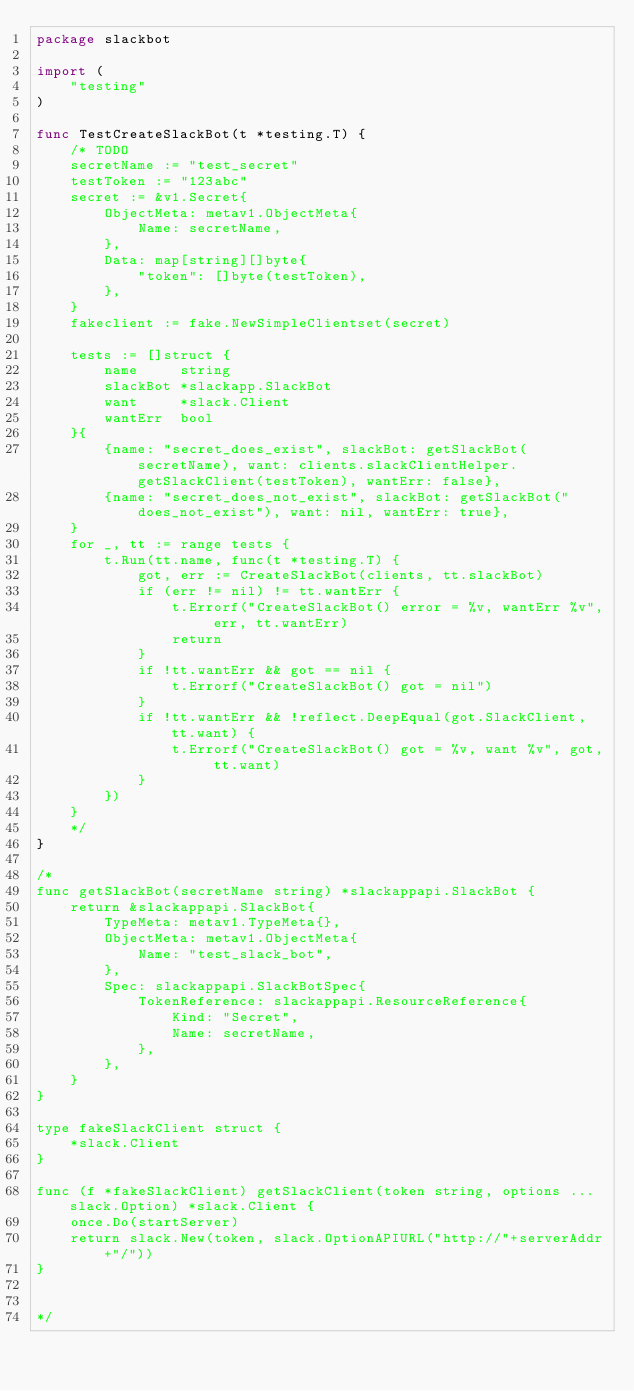Convert code to text. <code><loc_0><loc_0><loc_500><loc_500><_Go_>package slackbot

import (
	"testing"
)

func TestCreateSlackBot(t *testing.T) {
	/* TODO
	secretName := "test_secret"
	testToken := "123abc"
	secret := &v1.Secret{
		ObjectMeta: metav1.ObjectMeta{
			Name: secretName,
		},
		Data: map[string][]byte{
			"token": []byte(testToken),
		},
	}
	fakeclient := fake.NewSimpleClientset(secret)

	tests := []struct {
		name     string
		slackBot *slackapp.SlackBot
		want     *slack.Client
		wantErr  bool
	}{
		{name: "secret_does_exist", slackBot: getSlackBot(secretName), want: clients.slackClientHelper.getSlackClient(testToken), wantErr: false},
		{name: "secret_does_not_exist", slackBot: getSlackBot("does_not_exist"), want: nil, wantErr: true},
	}
	for _, tt := range tests {
		t.Run(tt.name, func(t *testing.T) {
			got, err := CreateSlackBot(clients, tt.slackBot)
			if (err != nil) != tt.wantErr {
				t.Errorf("CreateSlackBot() error = %v, wantErr %v", err, tt.wantErr)
				return
			}
			if !tt.wantErr && got == nil {
				t.Errorf("CreateSlackBot() got = nil")
			}
			if !tt.wantErr && !reflect.DeepEqual(got.SlackClient, tt.want) {
				t.Errorf("CreateSlackBot() got = %v, want %v", got, tt.want)
			}
		})
	}
	*/
}

/*
func getSlackBot(secretName string) *slackappapi.SlackBot {
	return &slackappapi.SlackBot{
		TypeMeta: metav1.TypeMeta{},
		ObjectMeta: metav1.ObjectMeta{
			Name: "test_slack_bot",
		},
		Spec: slackappapi.SlackBotSpec{
			TokenReference: slackappapi.ResourceReference{
				Kind: "Secret",
				Name: secretName,
			},
		},
	}
}

type fakeSlackClient struct {
	*slack.Client
}

func (f *fakeSlackClient) getSlackClient(token string, options ...slack.Option) *slack.Client {
	once.Do(startServer)
	return slack.New(token, slack.OptionAPIURL("http://"+serverAddr+"/"))
}


*/
</code> 